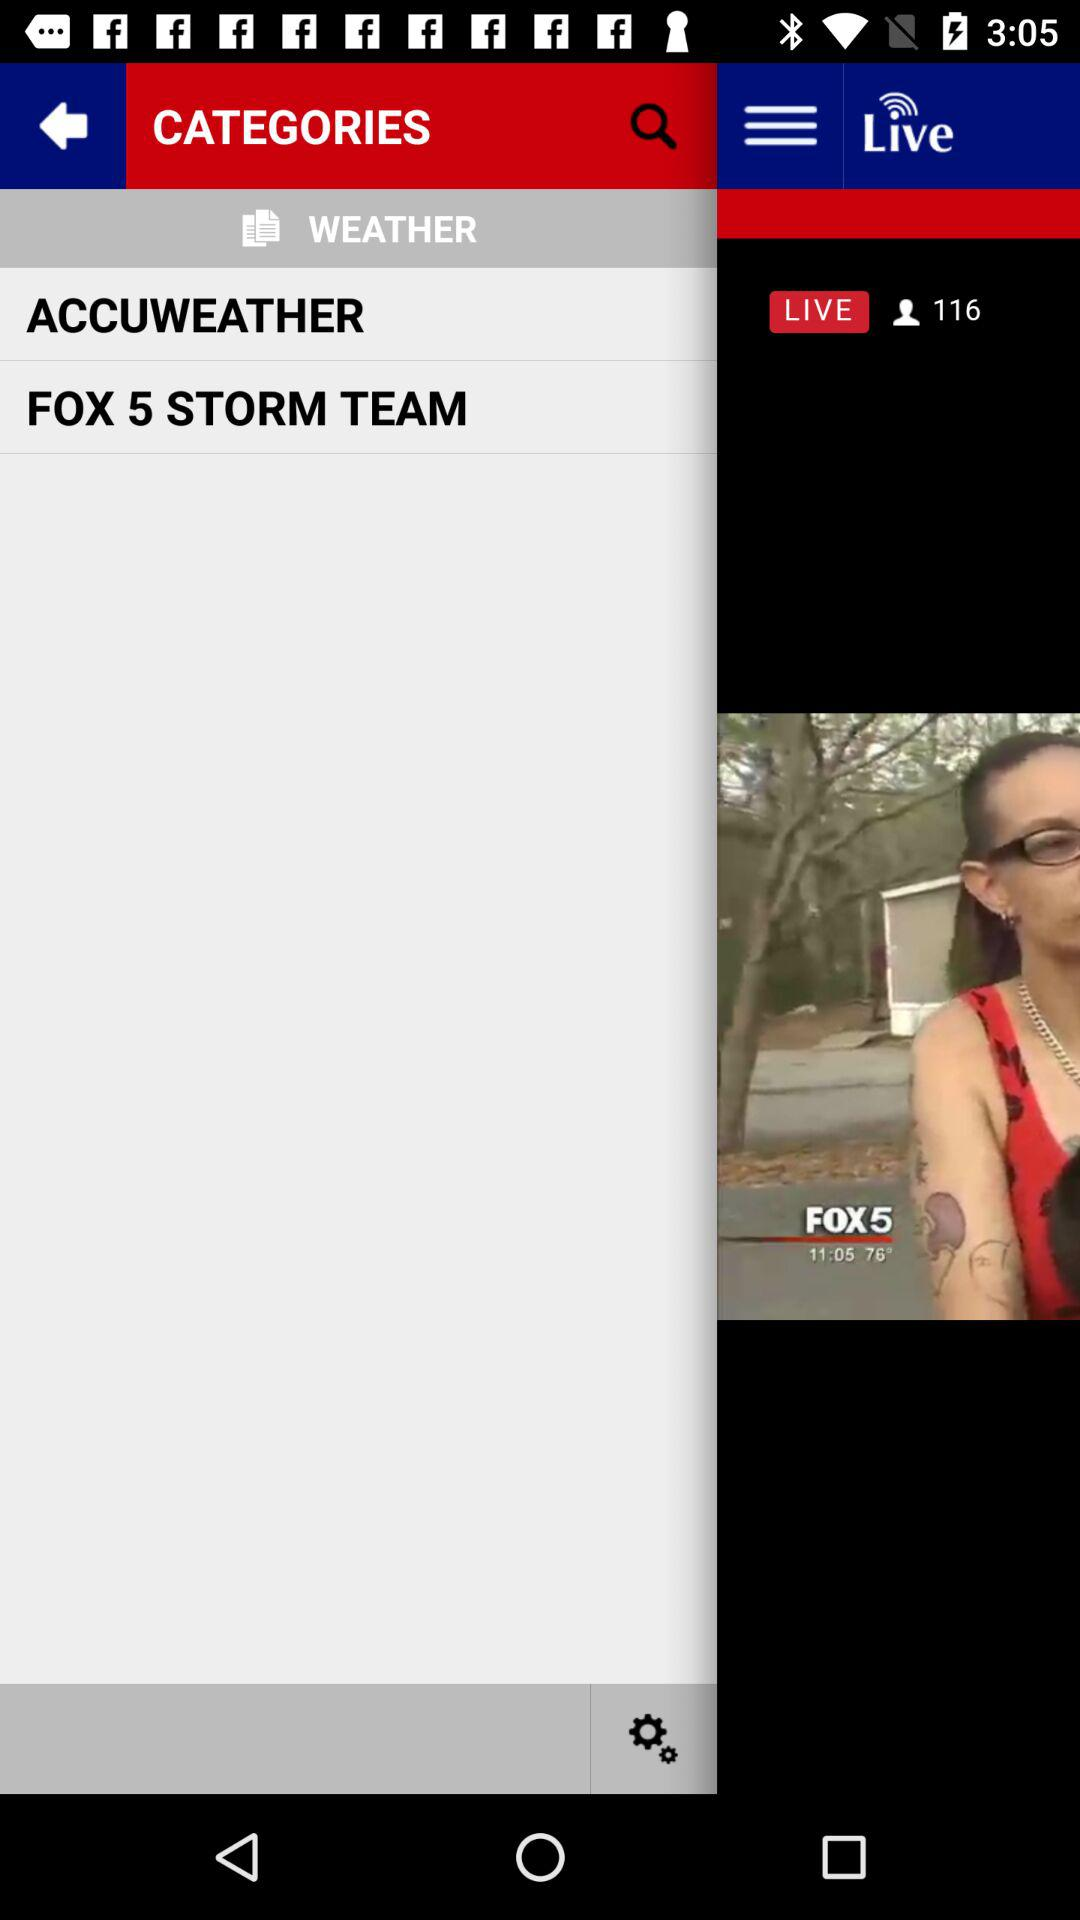What is the total number of articles? The total number of articles is 15. 